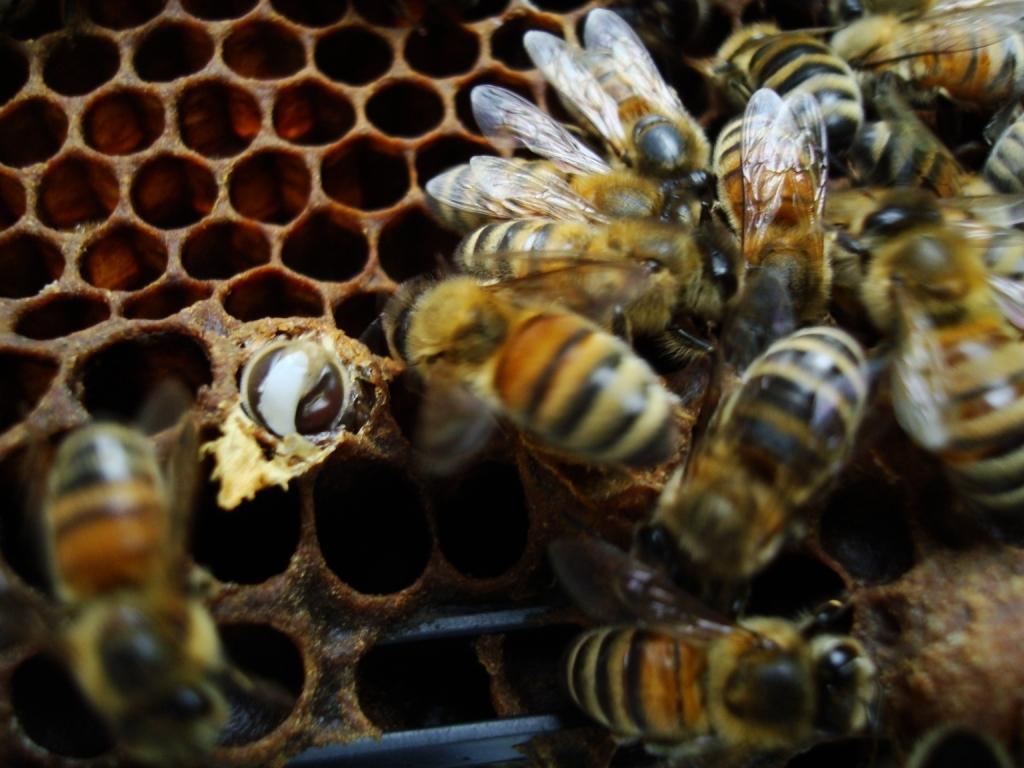Could you give a brief overview of what you see in this image? In this picture we can see honey bees on a nest. 